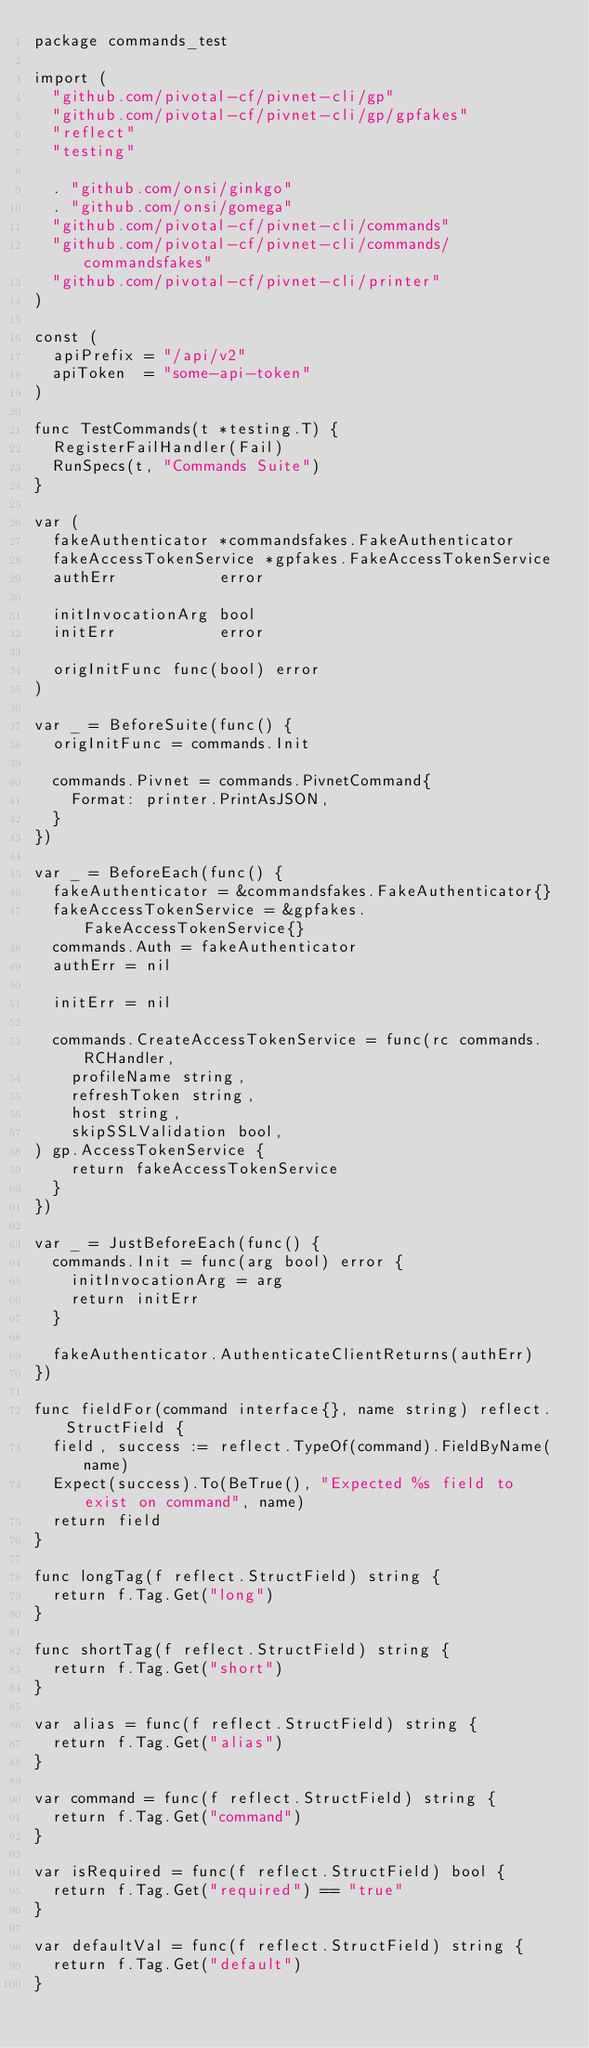<code> <loc_0><loc_0><loc_500><loc_500><_Go_>package commands_test

import (
	"github.com/pivotal-cf/pivnet-cli/gp"
	"github.com/pivotal-cf/pivnet-cli/gp/gpfakes"
	"reflect"
	"testing"

	. "github.com/onsi/ginkgo"
	. "github.com/onsi/gomega"
	"github.com/pivotal-cf/pivnet-cli/commands"
	"github.com/pivotal-cf/pivnet-cli/commands/commandsfakes"
	"github.com/pivotal-cf/pivnet-cli/printer"
)

const (
	apiPrefix = "/api/v2"
	apiToken  = "some-api-token"
)

func TestCommands(t *testing.T) {
	RegisterFailHandler(Fail)
	RunSpecs(t, "Commands Suite")
}

var (
	fakeAuthenticator *commandsfakes.FakeAuthenticator
	fakeAccessTokenService *gpfakes.FakeAccessTokenService
	authErr           error

	initInvocationArg bool
	initErr           error

	origInitFunc func(bool) error
)

var _ = BeforeSuite(func() {
	origInitFunc = commands.Init

	commands.Pivnet = commands.PivnetCommand{
		Format: printer.PrintAsJSON,
	}
})

var _ = BeforeEach(func() {
	fakeAuthenticator = &commandsfakes.FakeAuthenticator{}
	fakeAccessTokenService = &gpfakes.FakeAccessTokenService{}
	commands.Auth = fakeAuthenticator
	authErr = nil

	initErr = nil

	commands.CreateAccessTokenService = func(rc commands.RCHandler,
		profileName string,
		refreshToken string,
		host string,
		skipSSLValidation bool,
) gp.AccessTokenService {
		return fakeAccessTokenService
	}
})

var _ = JustBeforeEach(func() {
	commands.Init = func(arg bool) error {
		initInvocationArg = arg
		return initErr
	}

	fakeAuthenticator.AuthenticateClientReturns(authErr)
})

func fieldFor(command interface{}, name string) reflect.StructField {
	field, success := reflect.TypeOf(command).FieldByName(name)
	Expect(success).To(BeTrue(), "Expected %s field to exist on command", name)
	return field
}

func longTag(f reflect.StructField) string {
	return f.Tag.Get("long")
}

func shortTag(f reflect.StructField) string {
	return f.Tag.Get("short")
}

var alias = func(f reflect.StructField) string {
	return f.Tag.Get("alias")
}

var command = func(f reflect.StructField) string {
	return f.Tag.Get("command")
}

var isRequired = func(f reflect.StructField) bool {
	return f.Tag.Get("required") == "true"
}

var defaultVal = func(f reflect.StructField) string {
	return f.Tag.Get("default")
}
</code> 